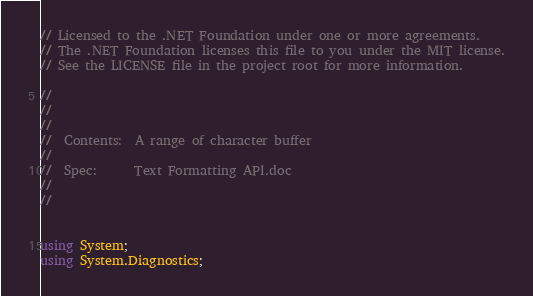Convert code to text. <code><loc_0><loc_0><loc_500><loc_500><_C#_>// Licensed to the .NET Foundation under one or more agreements.
// The .NET Foundation licenses this file to you under the MIT license.
// See the LICENSE file in the project root for more information.

//
//
//
//  Contents:  A range of character buffer
//
//  Spec:      Text Formatting API.doc
//
//


using System;
using System.Diagnostics;</code> 